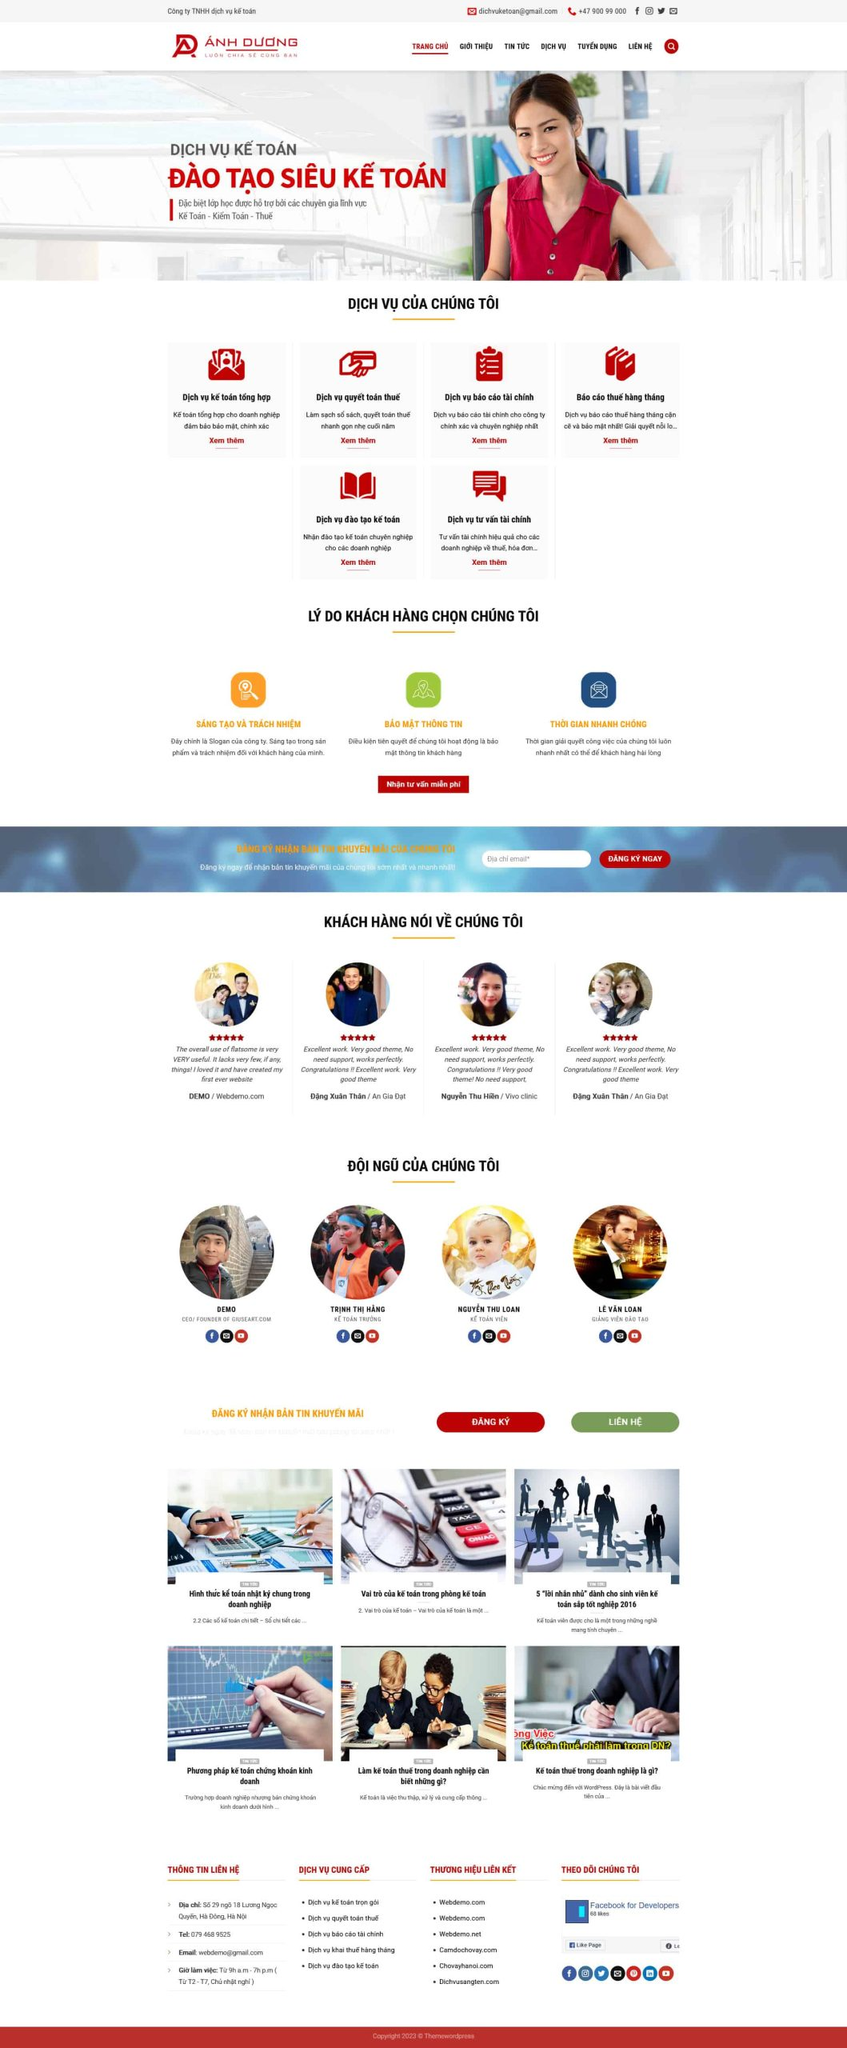Liệt kê 5 ngành nghề, lĩnh vực phù hợp với website này, phân cách các màu sắc bằng dấu phẩy. Chỉ trả về kết quả, phân cách bằng dấy phẩy
 Kế toán, Kiểm toán, Tư vấn tài chính, Đào tạo kế toán, Báo cáo tài chính 